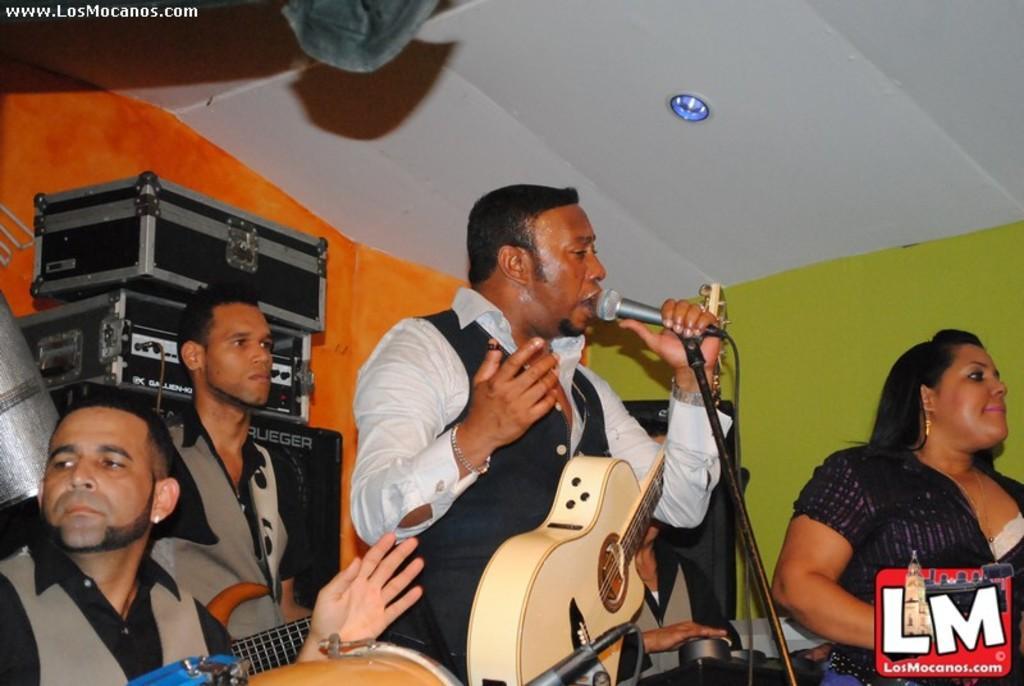Please provide a concise description of this image. In the middle there is a man he wear white shirt and suit. he hold guitar and mic ,i think he is singing. On the right there is a woman , she wear a black dress she is staring at something. On the left there are two man there are staring at something. At the top there is a light. In the background there is a wall with different colors. 